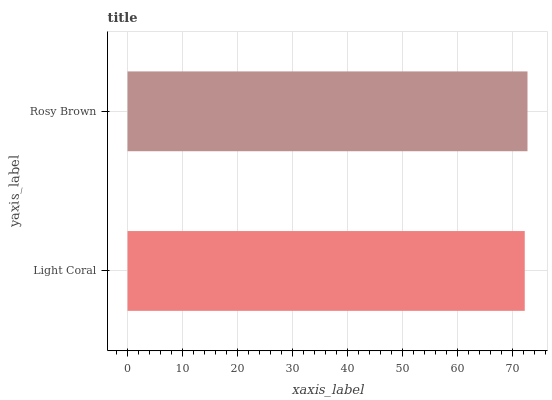Is Light Coral the minimum?
Answer yes or no. Yes. Is Rosy Brown the maximum?
Answer yes or no. Yes. Is Rosy Brown the minimum?
Answer yes or no. No. Is Rosy Brown greater than Light Coral?
Answer yes or no. Yes. Is Light Coral less than Rosy Brown?
Answer yes or no. Yes. Is Light Coral greater than Rosy Brown?
Answer yes or no. No. Is Rosy Brown less than Light Coral?
Answer yes or no. No. Is Rosy Brown the high median?
Answer yes or no. Yes. Is Light Coral the low median?
Answer yes or no. Yes. Is Light Coral the high median?
Answer yes or no. No. Is Rosy Brown the low median?
Answer yes or no. No. 